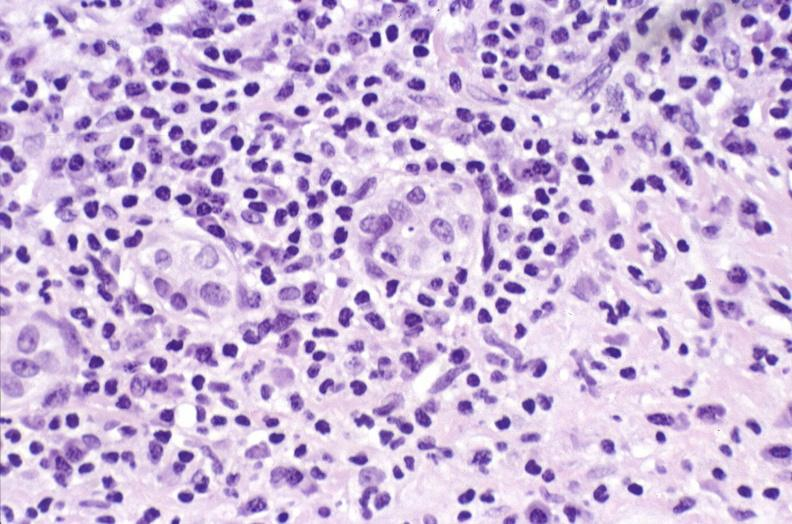what does this image show?
Answer the question using a single word or phrase. Primary biliary cirrhosis 